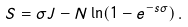<formula> <loc_0><loc_0><loc_500><loc_500>S = \sigma J - N \ln ( 1 - e ^ { - s \sigma } ) \, .</formula> 